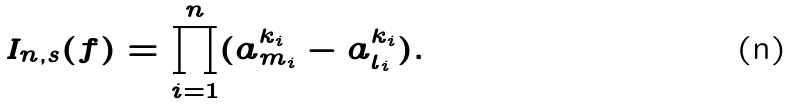<formula> <loc_0><loc_0><loc_500><loc_500>I _ { n , s } ( f ) = \prod _ { i = 1 } ^ { n } ( a _ { m _ { i } } ^ { k _ { i } } - a _ { l _ { i } } ^ { k _ { i } } ) .</formula> 